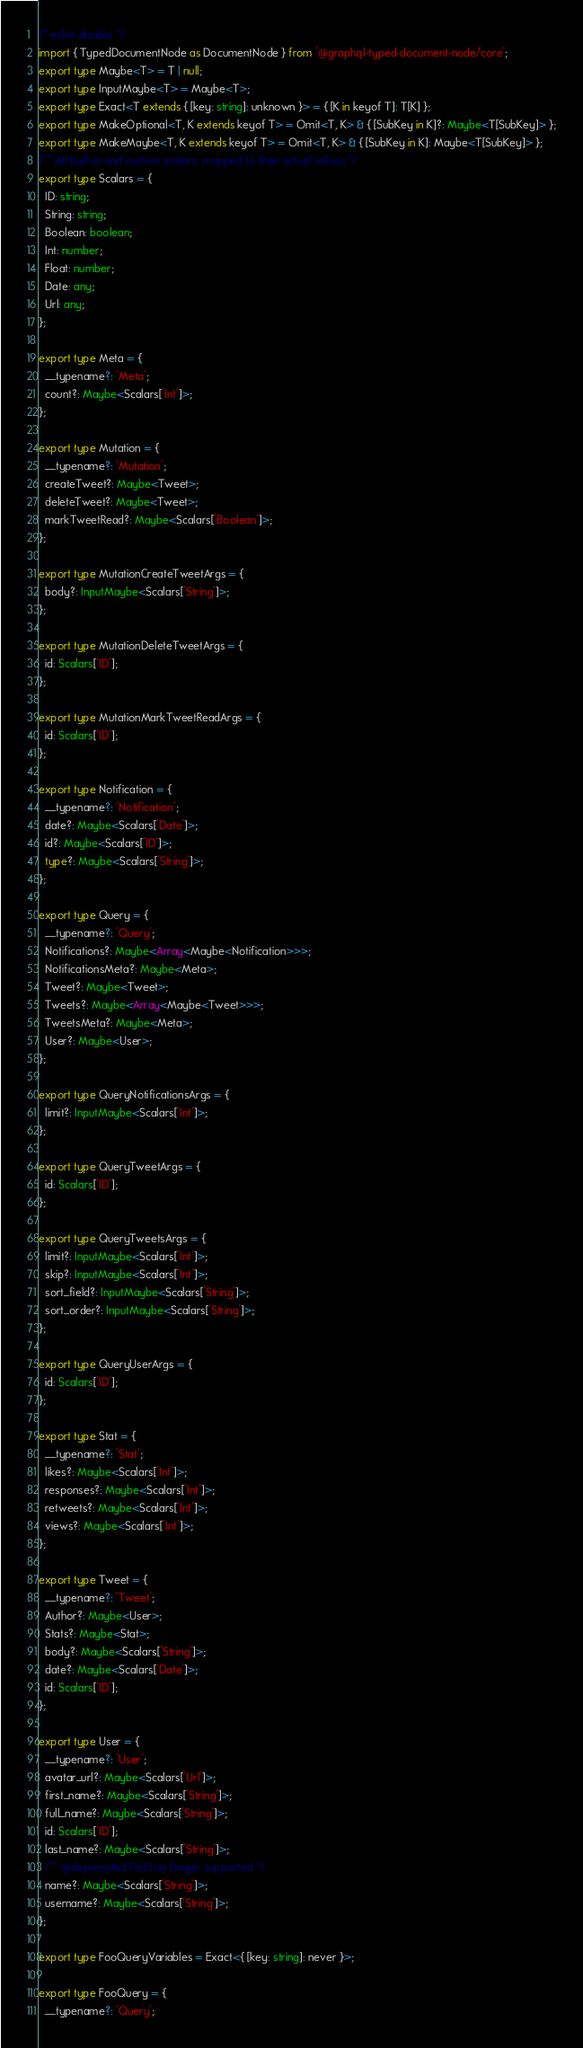<code> <loc_0><loc_0><loc_500><loc_500><_TypeScript_>/* eslint-disable */
import { TypedDocumentNode as DocumentNode } from '@graphql-typed-document-node/core';
export type Maybe<T> = T | null;
export type InputMaybe<T> = Maybe<T>;
export type Exact<T extends { [key: string]: unknown }> = { [K in keyof T]: T[K] };
export type MakeOptional<T, K extends keyof T> = Omit<T, K> & { [SubKey in K]?: Maybe<T[SubKey]> };
export type MakeMaybe<T, K extends keyof T> = Omit<T, K> & { [SubKey in K]: Maybe<T[SubKey]> };
/** All built-in and custom scalars, mapped to their actual values */
export type Scalars = {
  ID: string;
  String: string;
  Boolean: boolean;
  Int: number;
  Float: number;
  Date: any;
  Url: any;
};

export type Meta = {
  __typename?: 'Meta';
  count?: Maybe<Scalars['Int']>;
};

export type Mutation = {
  __typename?: 'Mutation';
  createTweet?: Maybe<Tweet>;
  deleteTweet?: Maybe<Tweet>;
  markTweetRead?: Maybe<Scalars['Boolean']>;
};

export type MutationCreateTweetArgs = {
  body?: InputMaybe<Scalars['String']>;
};

export type MutationDeleteTweetArgs = {
  id: Scalars['ID'];
};

export type MutationMarkTweetReadArgs = {
  id: Scalars['ID'];
};

export type Notification = {
  __typename?: 'Notification';
  date?: Maybe<Scalars['Date']>;
  id?: Maybe<Scalars['ID']>;
  type?: Maybe<Scalars['String']>;
};

export type Query = {
  __typename?: 'Query';
  Notifications?: Maybe<Array<Maybe<Notification>>>;
  NotificationsMeta?: Maybe<Meta>;
  Tweet?: Maybe<Tweet>;
  Tweets?: Maybe<Array<Maybe<Tweet>>>;
  TweetsMeta?: Maybe<Meta>;
  User?: Maybe<User>;
};

export type QueryNotificationsArgs = {
  limit?: InputMaybe<Scalars['Int']>;
};

export type QueryTweetArgs = {
  id: Scalars['ID'];
};

export type QueryTweetsArgs = {
  limit?: InputMaybe<Scalars['Int']>;
  skip?: InputMaybe<Scalars['Int']>;
  sort_field?: InputMaybe<Scalars['String']>;
  sort_order?: InputMaybe<Scalars['String']>;
};

export type QueryUserArgs = {
  id: Scalars['ID'];
};

export type Stat = {
  __typename?: 'Stat';
  likes?: Maybe<Scalars['Int']>;
  responses?: Maybe<Scalars['Int']>;
  retweets?: Maybe<Scalars['Int']>;
  views?: Maybe<Scalars['Int']>;
};

export type Tweet = {
  __typename?: 'Tweet';
  Author?: Maybe<User>;
  Stats?: Maybe<Stat>;
  body?: Maybe<Scalars['String']>;
  date?: Maybe<Scalars['Date']>;
  id: Scalars['ID'];
};

export type User = {
  __typename?: 'User';
  avatar_url?: Maybe<Scalars['Url']>;
  first_name?: Maybe<Scalars['String']>;
  full_name?: Maybe<Scalars['String']>;
  id: Scalars['ID'];
  last_name?: Maybe<Scalars['String']>;
  /** @deprecated Field no longer supported */
  name?: Maybe<Scalars['String']>;
  username?: Maybe<Scalars['String']>;
};

export type FooQueryVariables = Exact<{ [key: string]: never }>;

export type FooQuery = {
  __typename?: 'Query';</code> 